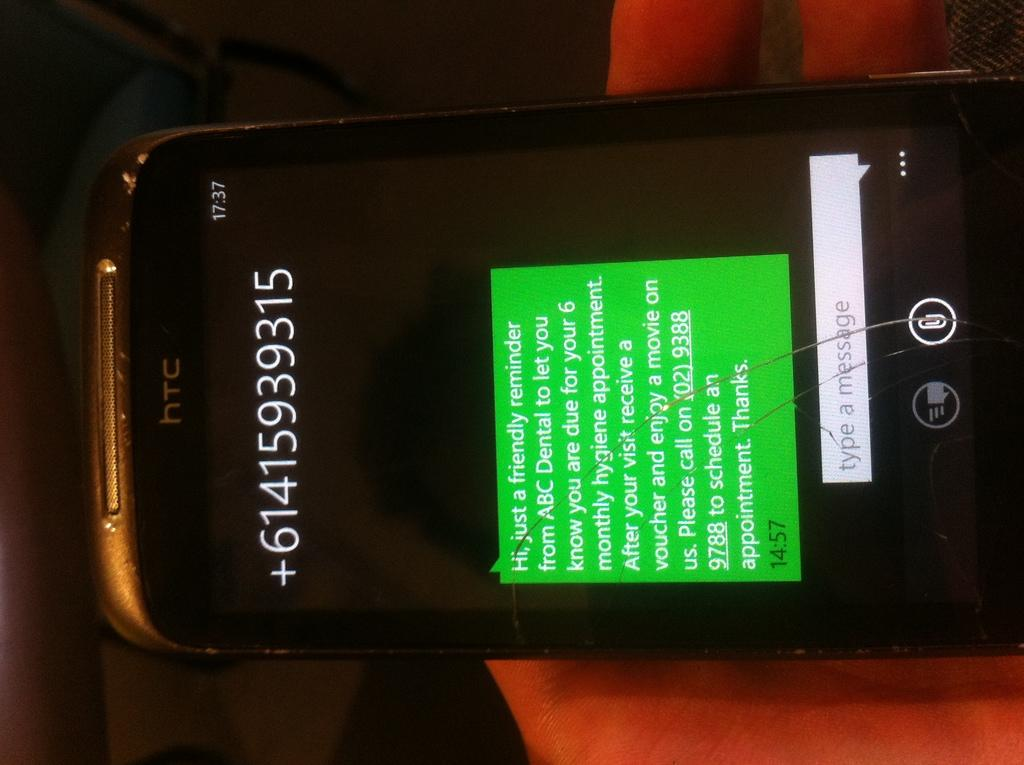<image>
Summarize the visual content of the image. A cell phone with a phone number across the top and a message from ABC saying it is a friendly reminder of an upcoming appointment. 